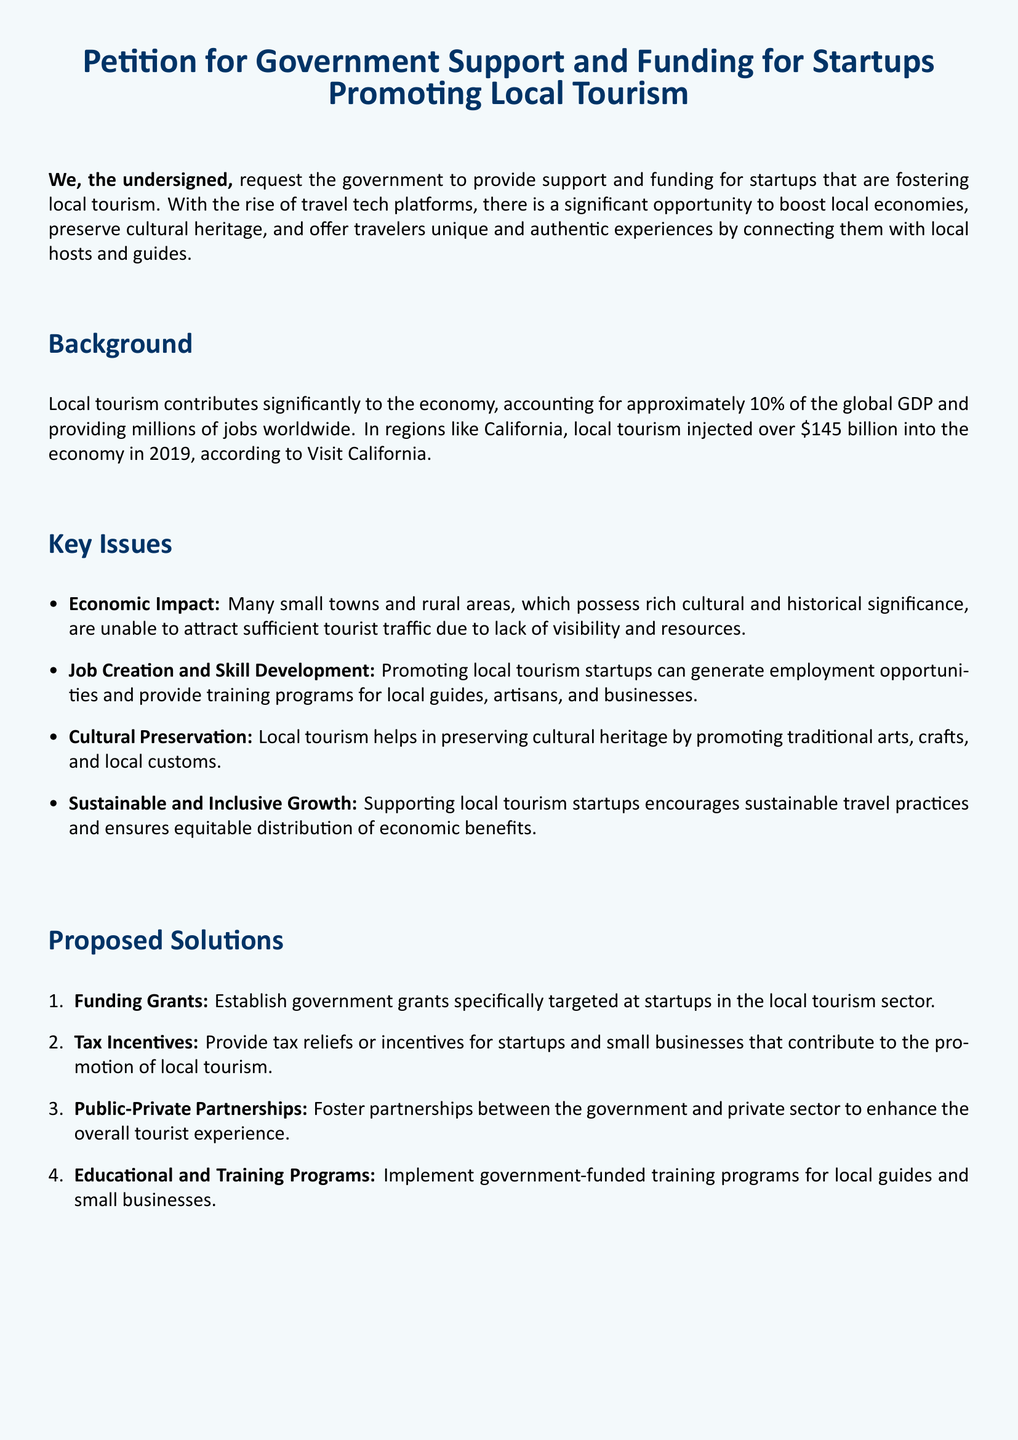What is the title of the petition? The title of the petition is stated at the beginning of the document.
Answer: Petition for Government Support and Funding for Startups Promoting Local Tourism What percentage of the global GDP does local tourism contribute? The document mentions the contribution of local tourism to the global GDP.
Answer: approximately 10% How much did local tourism inject into California's economy in 2019? The document provides a specific figure related to California's economy from local tourism.
Answer: over $145 billion What is one key issue mentioned regarding small towns? The document lists key issues related to local tourism, mentioning challenges faced by small towns.
Answer: lack of visibility and resources What is one proposed solution for supporting local tourism startups? The document suggests several solutions; one is explicitly mentioned.
Answer: Funding Grants Who is the co-founder of LocalTravelConnect according to the petition? The document lists signatories of the petition, including John Doe's affiliation.
Answer: John Doe What type of programs are proposed for local guides? The proposed solutions specify types of programs that could be implemented.
Answer: Educational and Training Programs What does supporting local tourism startups help preserve? The document refers to a specific cultural aspect that local tourism helps maintain.
Answer: cultural heritage 